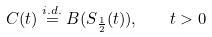<formula> <loc_0><loc_0><loc_500><loc_500>C ( t ) \stackrel { i . d . } { = } B ( S _ { \frac { 1 } { 2 } } ( t ) ) , \quad t > 0</formula> 